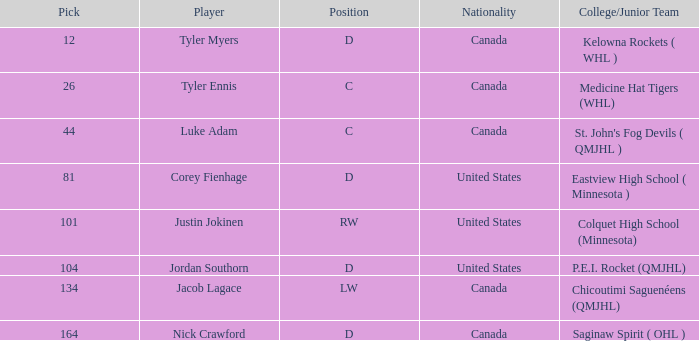What is the college/junior team of player tyler myers, who has a pick less than 44? Kelowna Rockets ( WHL ). 